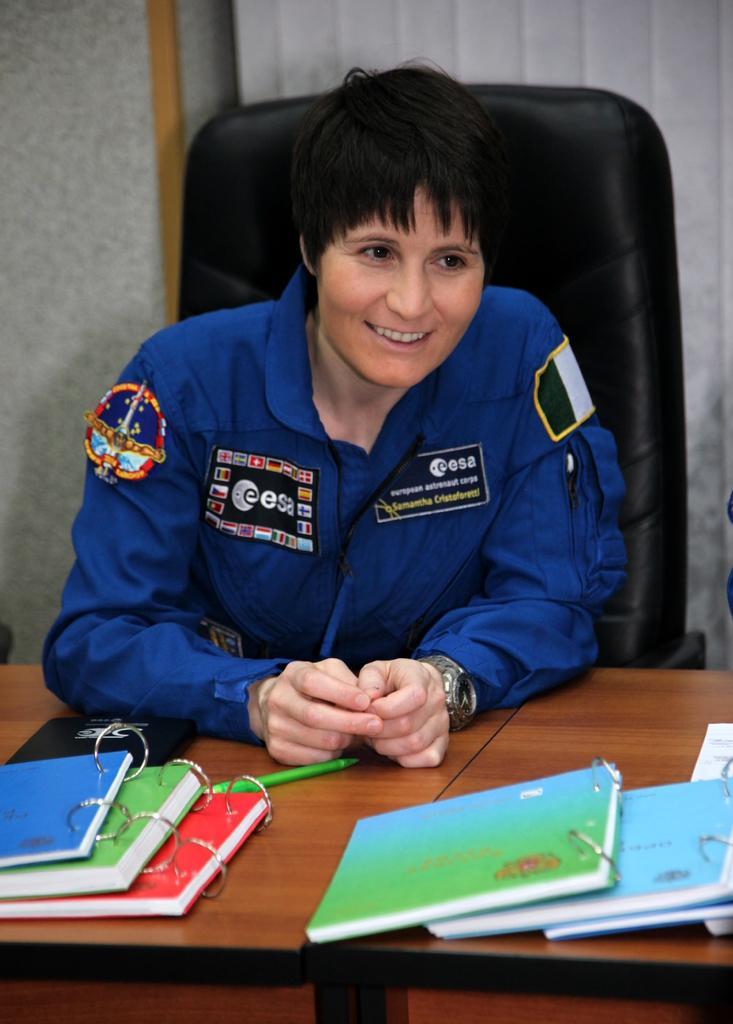How would you summarize this image in a sentence or two? In this image we can see a woman sitting on the chair and smiling. We can also see some books and a pen on the wooden table. In the background we can see the wall. 